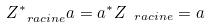<formula> <loc_0><loc_0><loc_500><loc_500>Z _ { \ r a c i n e } ^ { * } a = a ^ { * } Z _ { \ r a c i n e } = a</formula> 